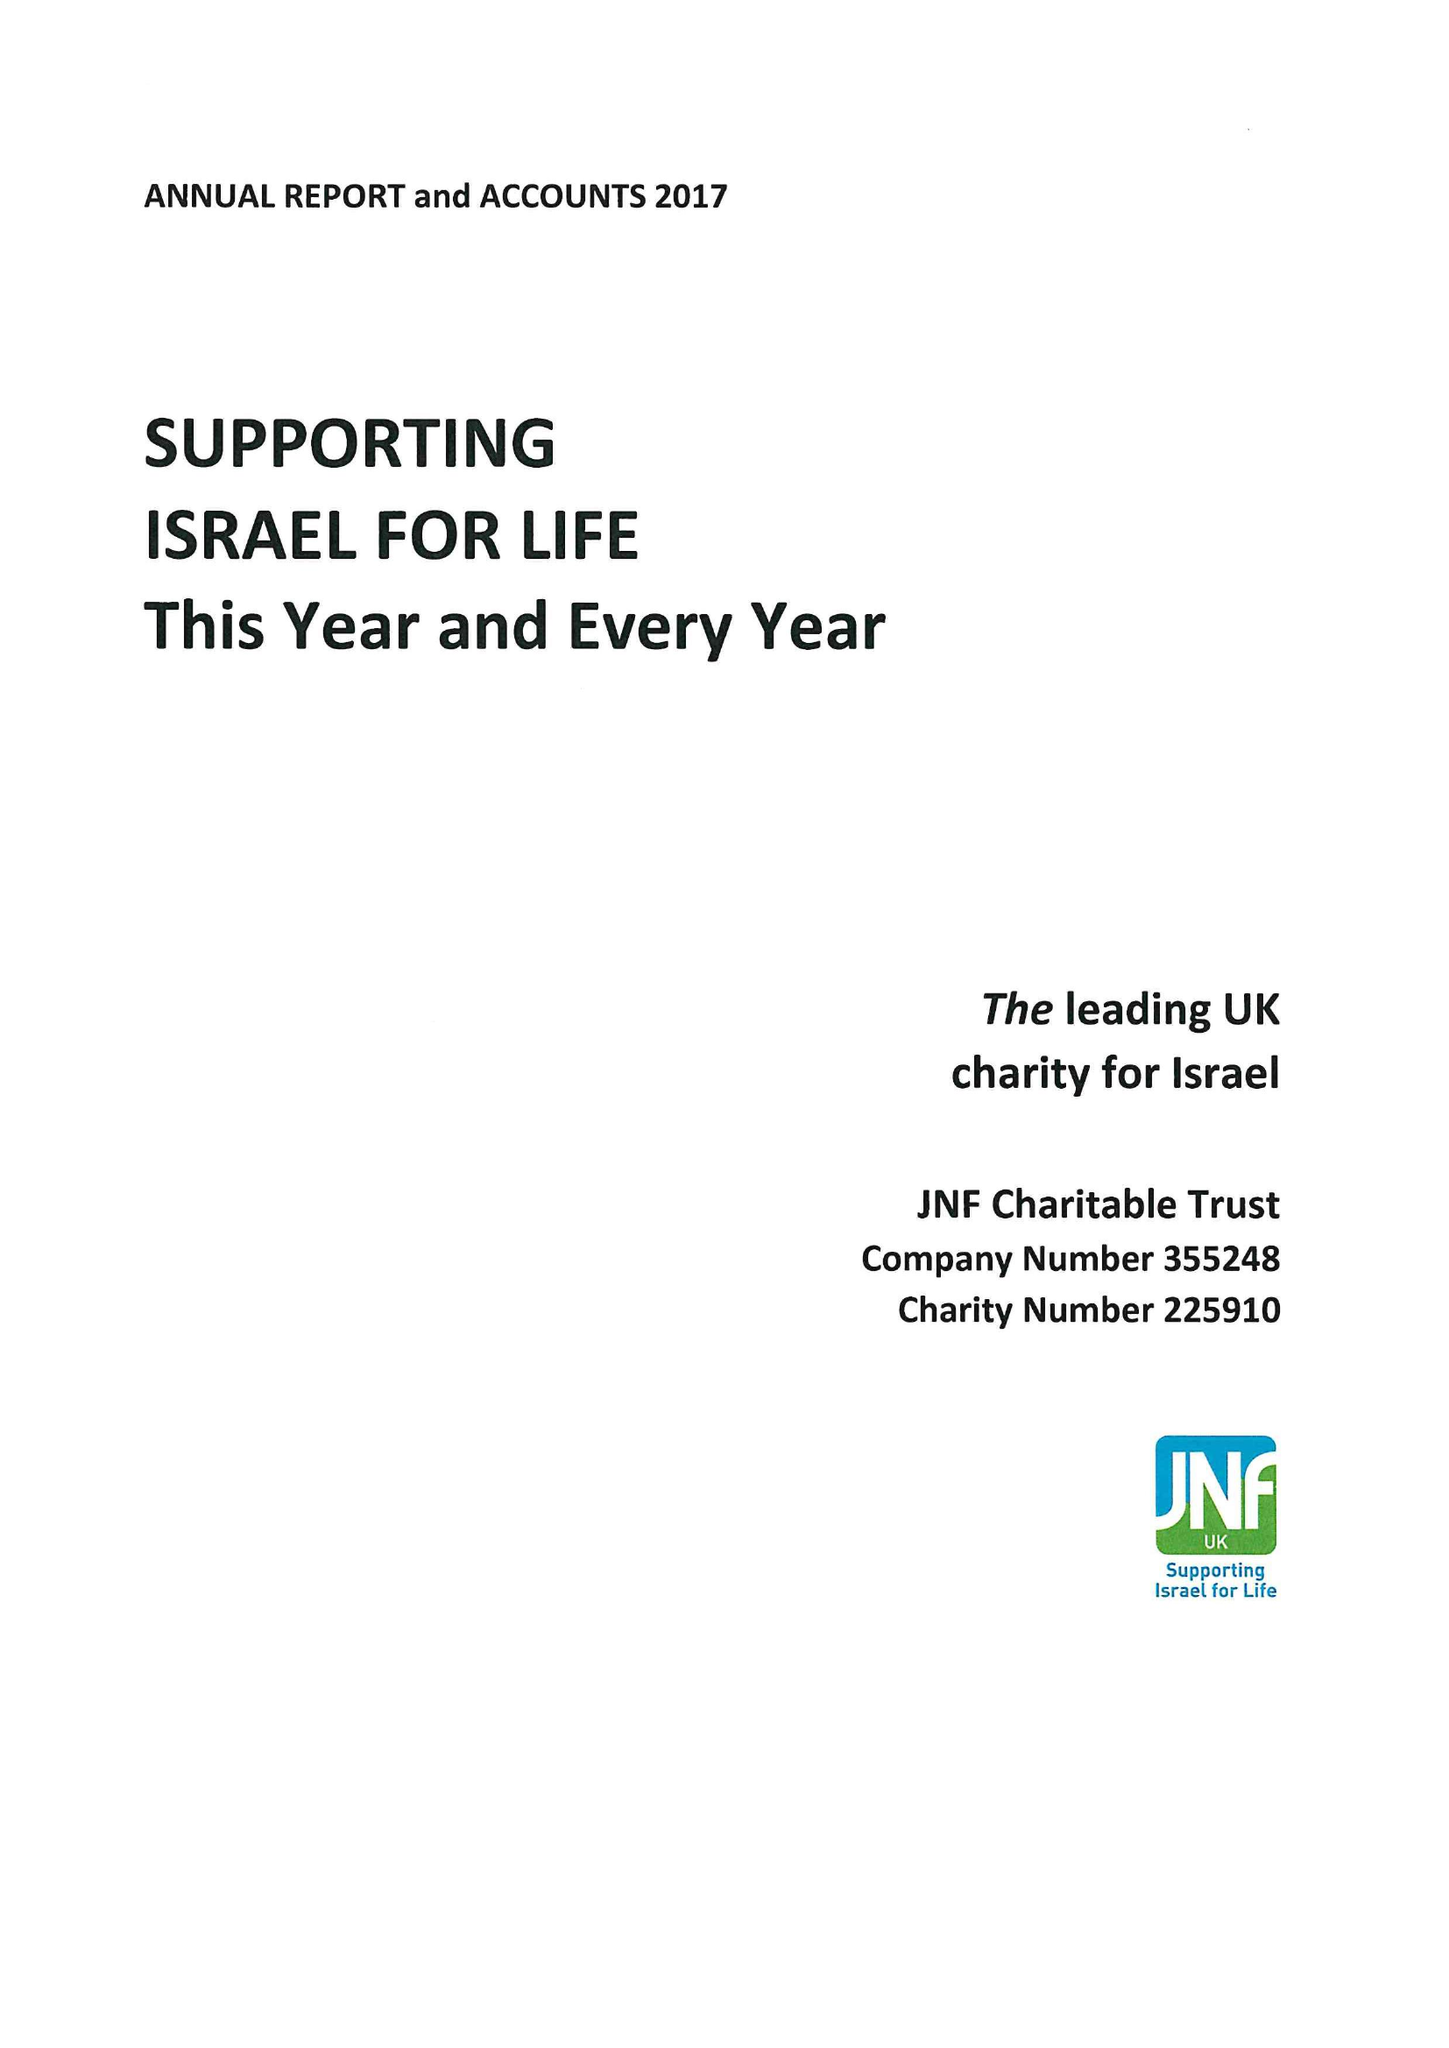What is the value for the charity_name?
Answer the question using a single word or phrase. Jnf Charitable Trust 